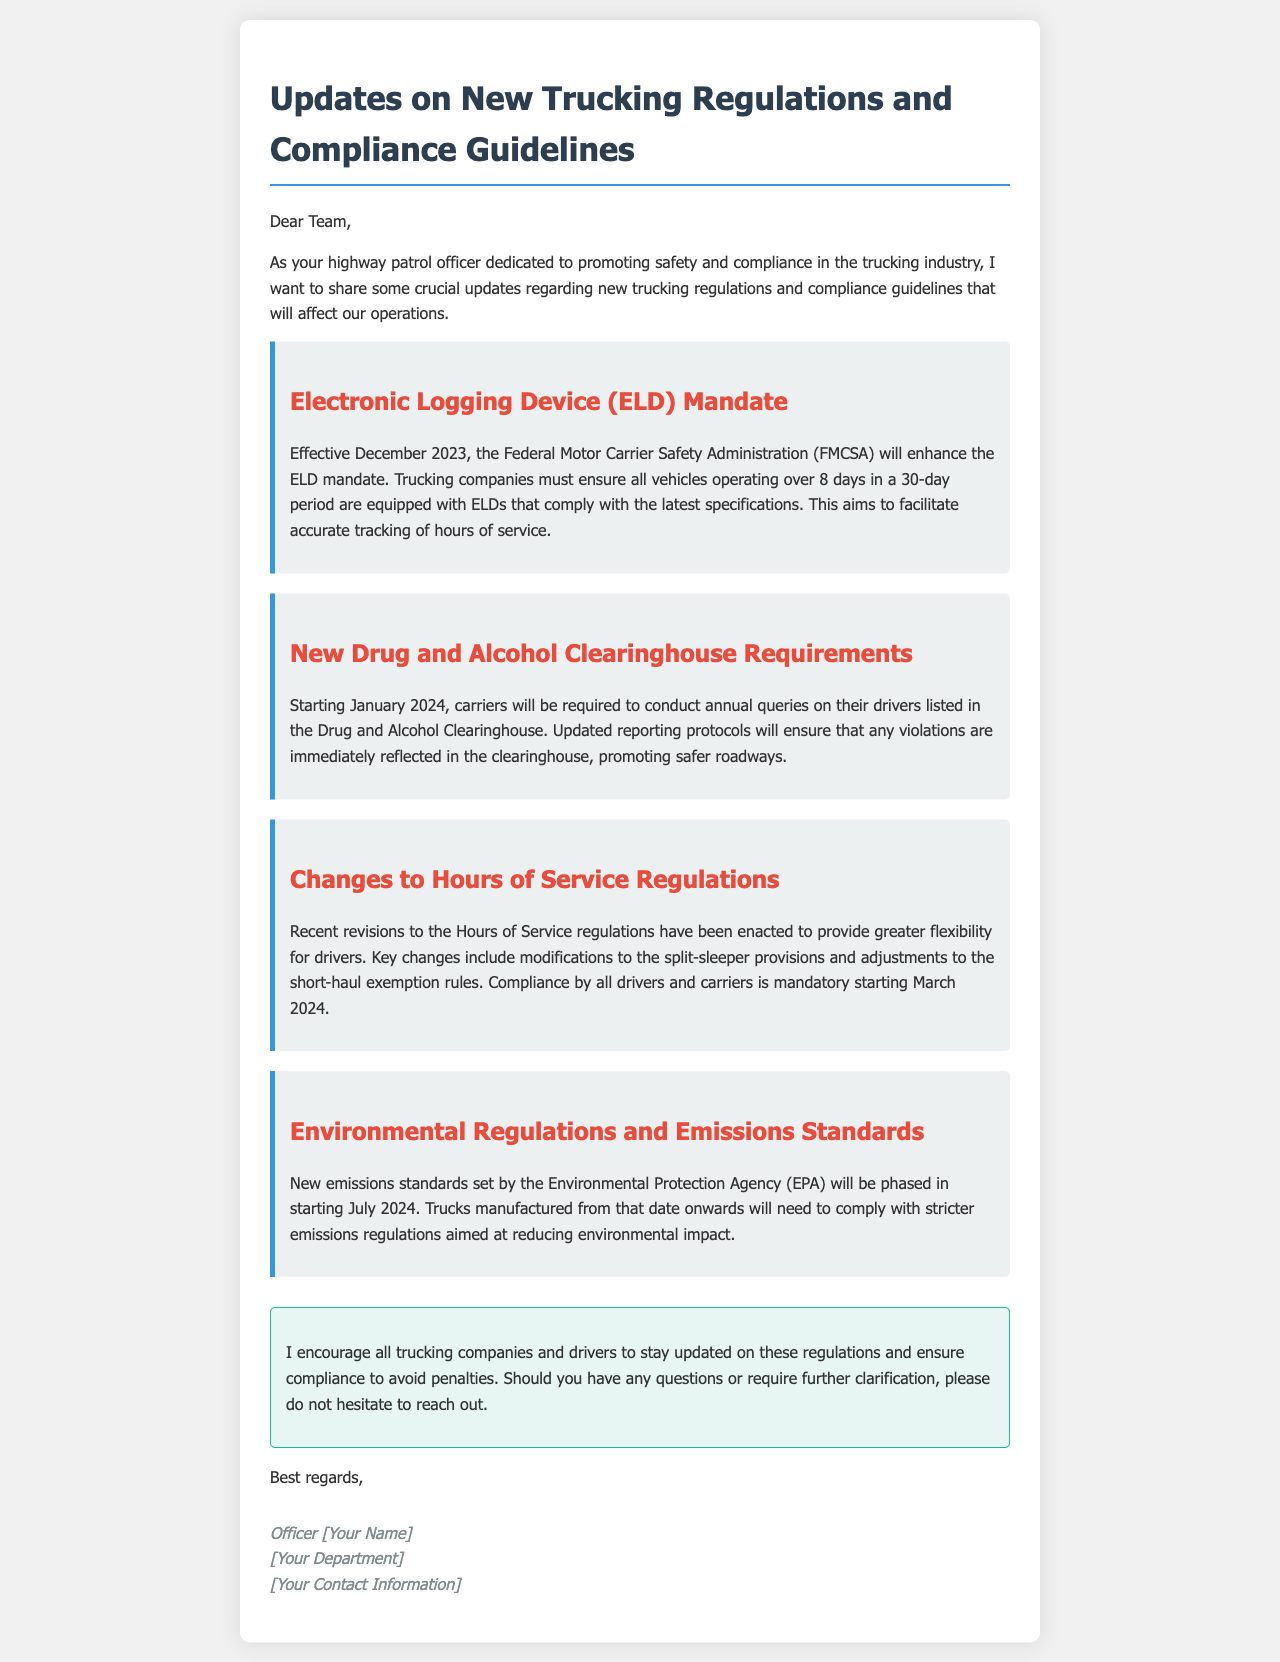What is the effective date for the ELD mandate? The ELD mandate will take effect in December 2023.
Answer: December 2023 What new requirement starts in January 2024? Carriers will be required to conduct annual queries on their drivers listed in the Drug and Alcohol Clearinghouse.
Answer: Annual queries When do the changes to Hours of Service Regulations become mandatory? The compliance by all drivers and carriers is mandatory starting March 2024.
Answer: March 2024 What organization set the new emissions standards? The Environmental Protection Agency (EPA) set the new emissions standards.
Answer: EPA What is the purpose of the enhanced ELD mandate? To facilitate accurate tracking of hours of service.
Answer: Accurate tracking How will the new drug and alcohol reporting protocols affect roadways? They will promote safer roadways by ensuring violations are immediately reflected.
Answer: Safer roadways What will happen to trucks manufactured from July 2024 onwards? They will need to comply with stricter emissions regulations.
Answer: Stricter emissions regulations What type of document is this? It is an email regarding updates on trucking regulations and compliance guidelines.
Answer: Email 